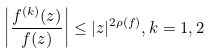Convert formula to latex. <formula><loc_0><loc_0><loc_500><loc_500>\left | \frac { f ^ { ( k ) } ( z ) } { f ( z ) } \right | \leq | z | ^ { 2 \rho ( f ) } , k = 1 , 2</formula> 